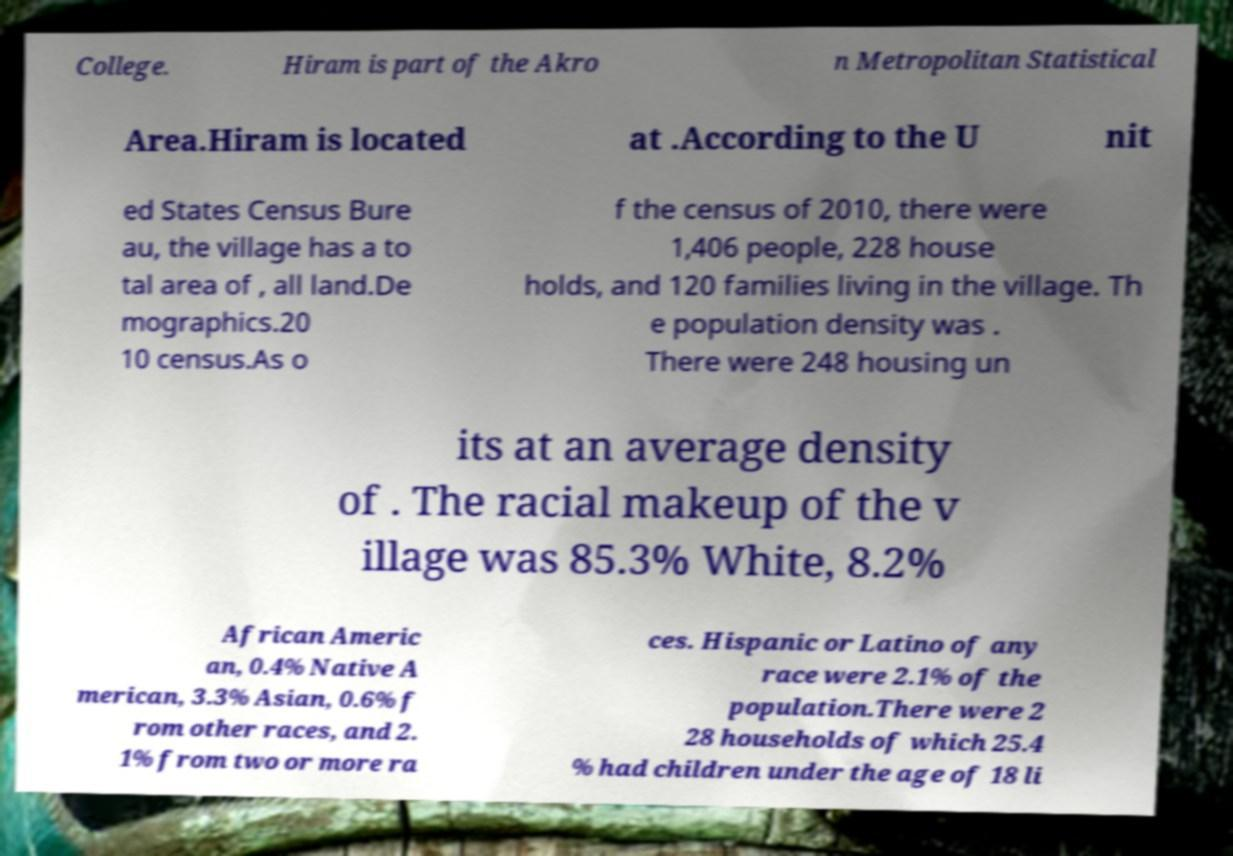Could you extract and type out the text from this image? College. Hiram is part of the Akro n Metropolitan Statistical Area.Hiram is located at .According to the U nit ed States Census Bure au, the village has a to tal area of , all land.De mographics.20 10 census.As o f the census of 2010, there were 1,406 people, 228 house holds, and 120 families living in the village. Th e population density was . There were 248 housing un its at an average density of . The racial makeup of the v illage was 85.3% White, 8.2% African Americ an, 0.4% Native A merican, 3.3% Asian, 0.6% f rom other races, and 2. 1% from two or more ra ces. Hispanic or Latino of any race were 2.1% of the population.There were 2 28 households of which 25.4 % had children under the age of 18 li 